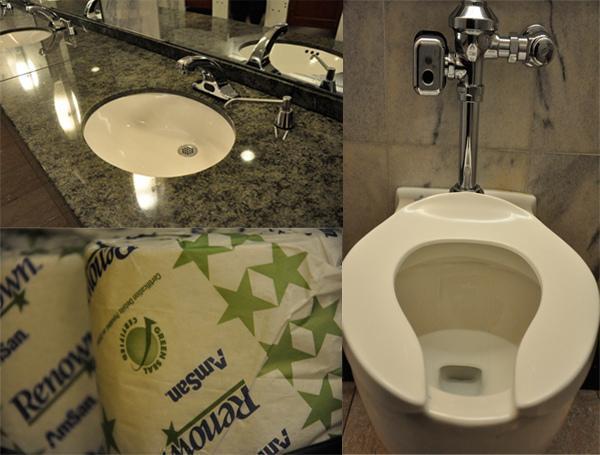How is the toilet flushed?
Make your selection from the four choices given to correctly answer the question.
Options: Pressure activated, ir beam, sound activated, manual handle. Ir beam. 